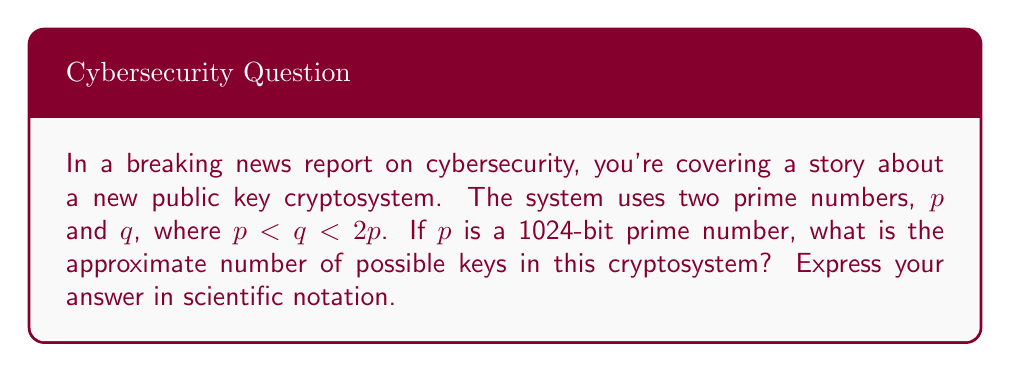Provide a solution to this math problem. Let's approach this step-by-step:

1) In a public key cryptosystem based on prime factorization (like RSA), the key is typically the product of two large prime numbers.

2) We're told that $p$ is a 1024-bit prime number. This means:

   $2^{1023} < p < 2^{1024}$

3) We're also told that $q < 2p$. So the maximum value of $q$ is just under $2^{1025}$.

4) The number of primes in this range can be estimated using the Prime Number Theorem. The density of primes near $x$ is approximately $\frac{1}{\ln(x)}$.

5) For $p$, the number of 1024-bit primes is approximately:

   $\frac{2^{1024} - 2^{1023}}{\ln(2^{1024})} \approx \frac{2^{1023}}{1024 \ln(2)} \approx 1.26 \times 10^{305}$

6) For $q$, the range is larger (from $p$ to $2p$), so we can estimate:

   $\frac{2^{1025} - 2^{1024}}{\ln(2^{1025})} \approx \frac{2^{1024}}{1025 \ln(2)} \approx 2.51 \times 10^{305}$

7) The total number of possible keys is the product of these two numbers:

   $(1.26 \times 10^{305})(2.51 \times 10^{305}) \approx 3.16 \times 10^{610}$

Therefore, the approximate number of possible keys is $3.16 \times 10^{610}$.
Answer: $3.16 \times 10^{610}$ 